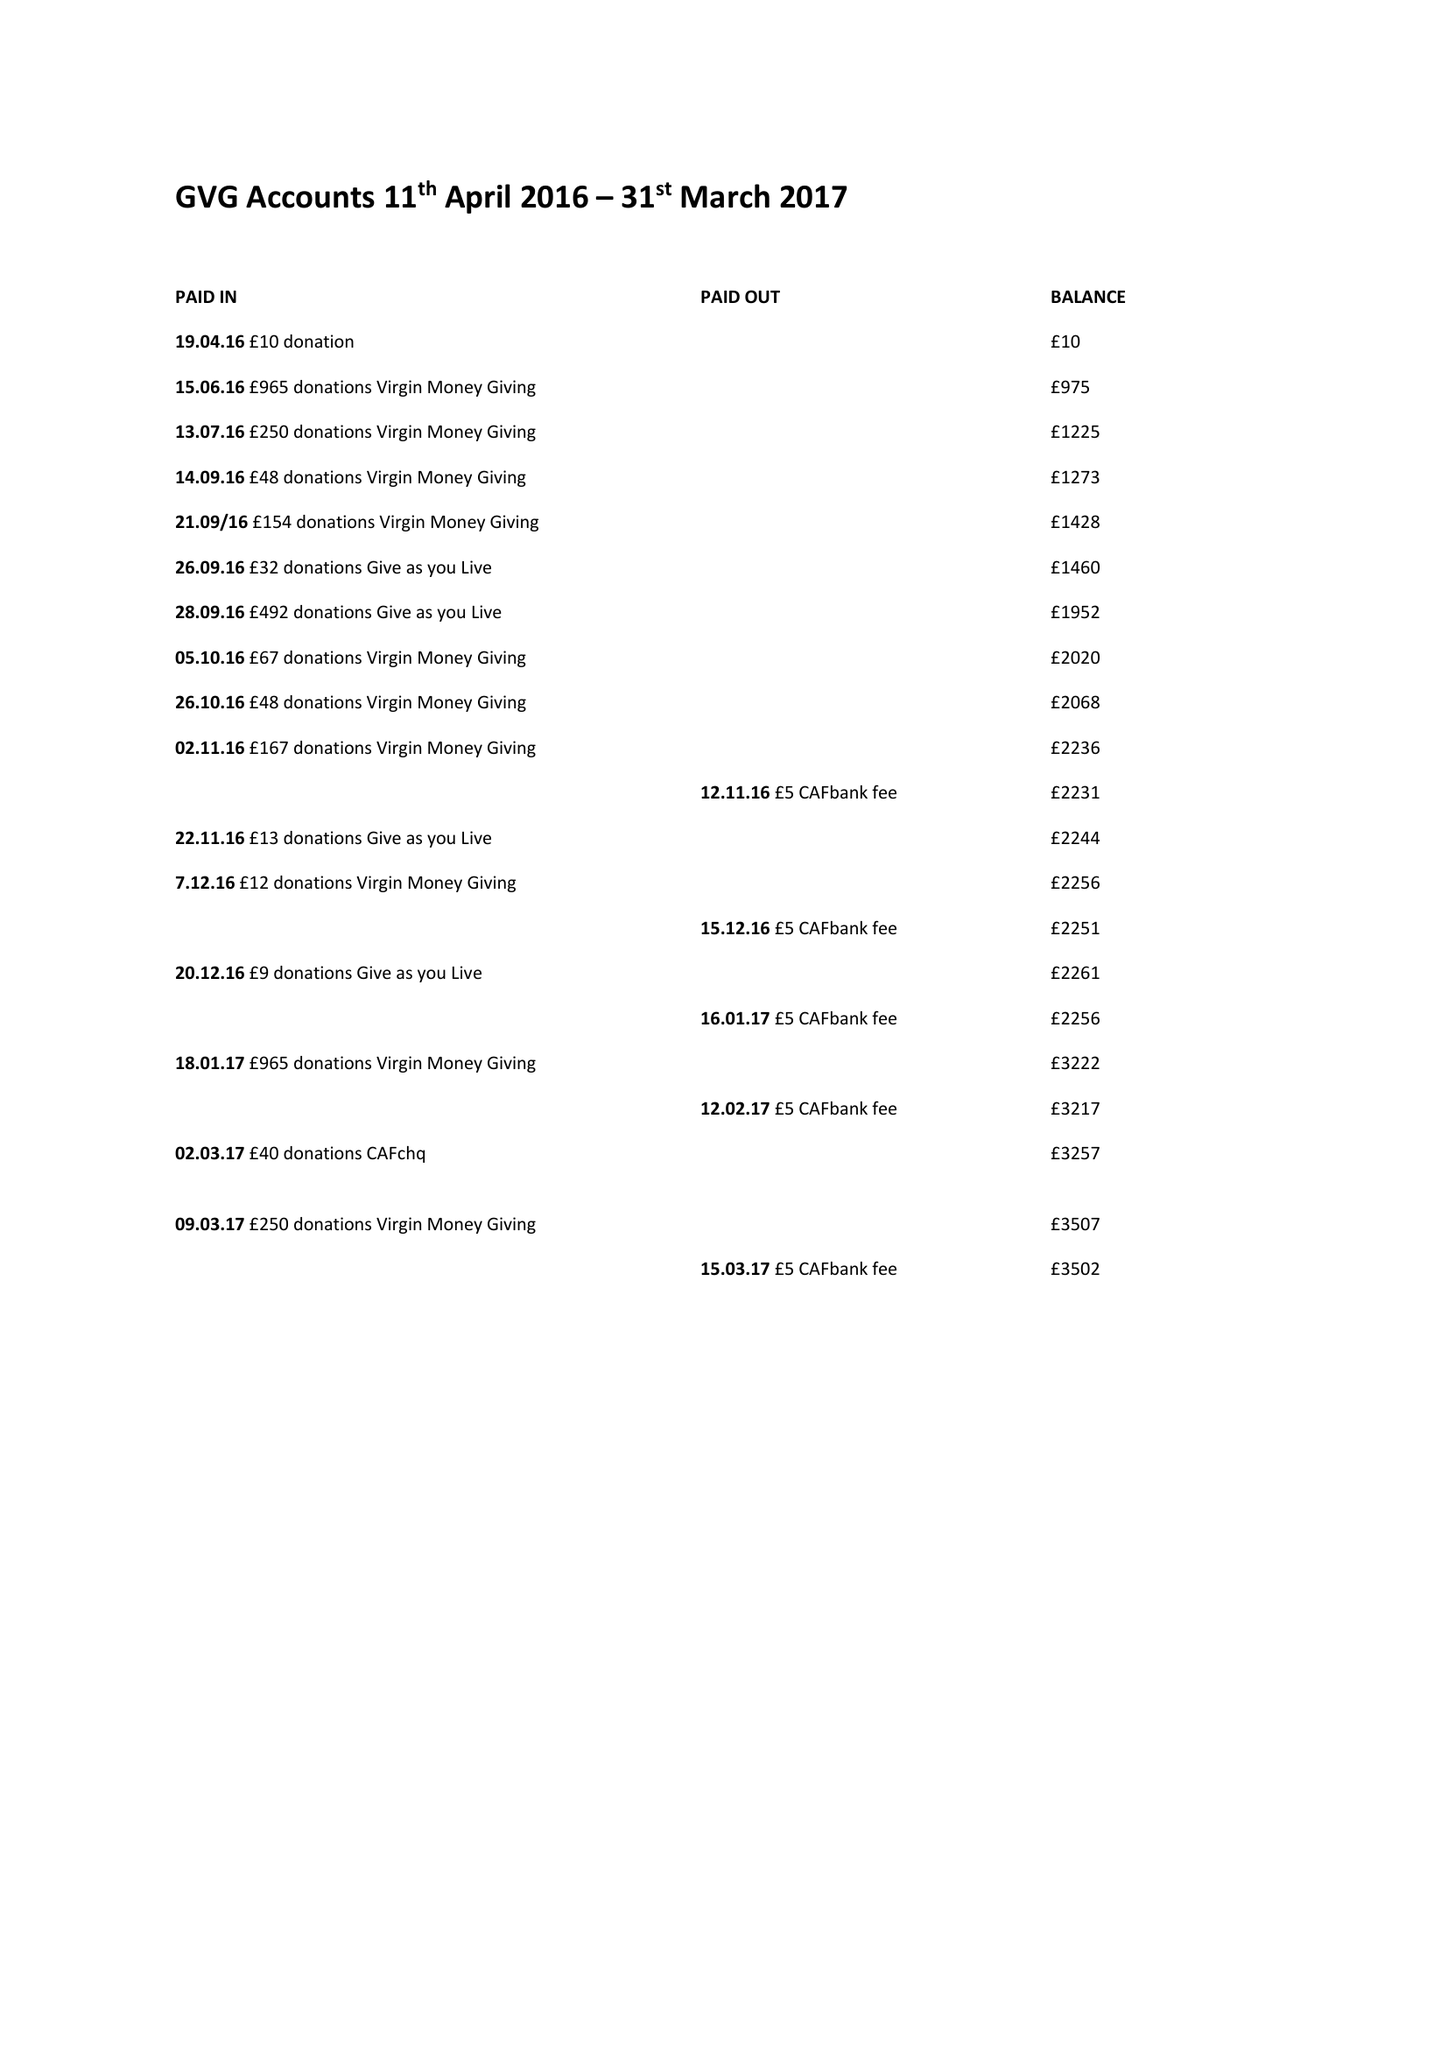What is the value for the charity_number?
Answer the question using a single word or phrase. 1166474 